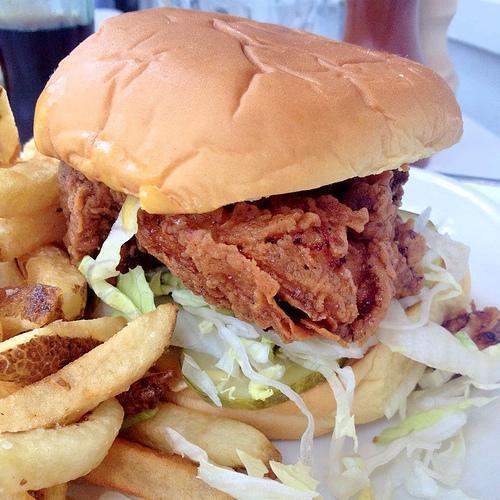How many burgers are in the photo?
Give a very brief answer. 1. 